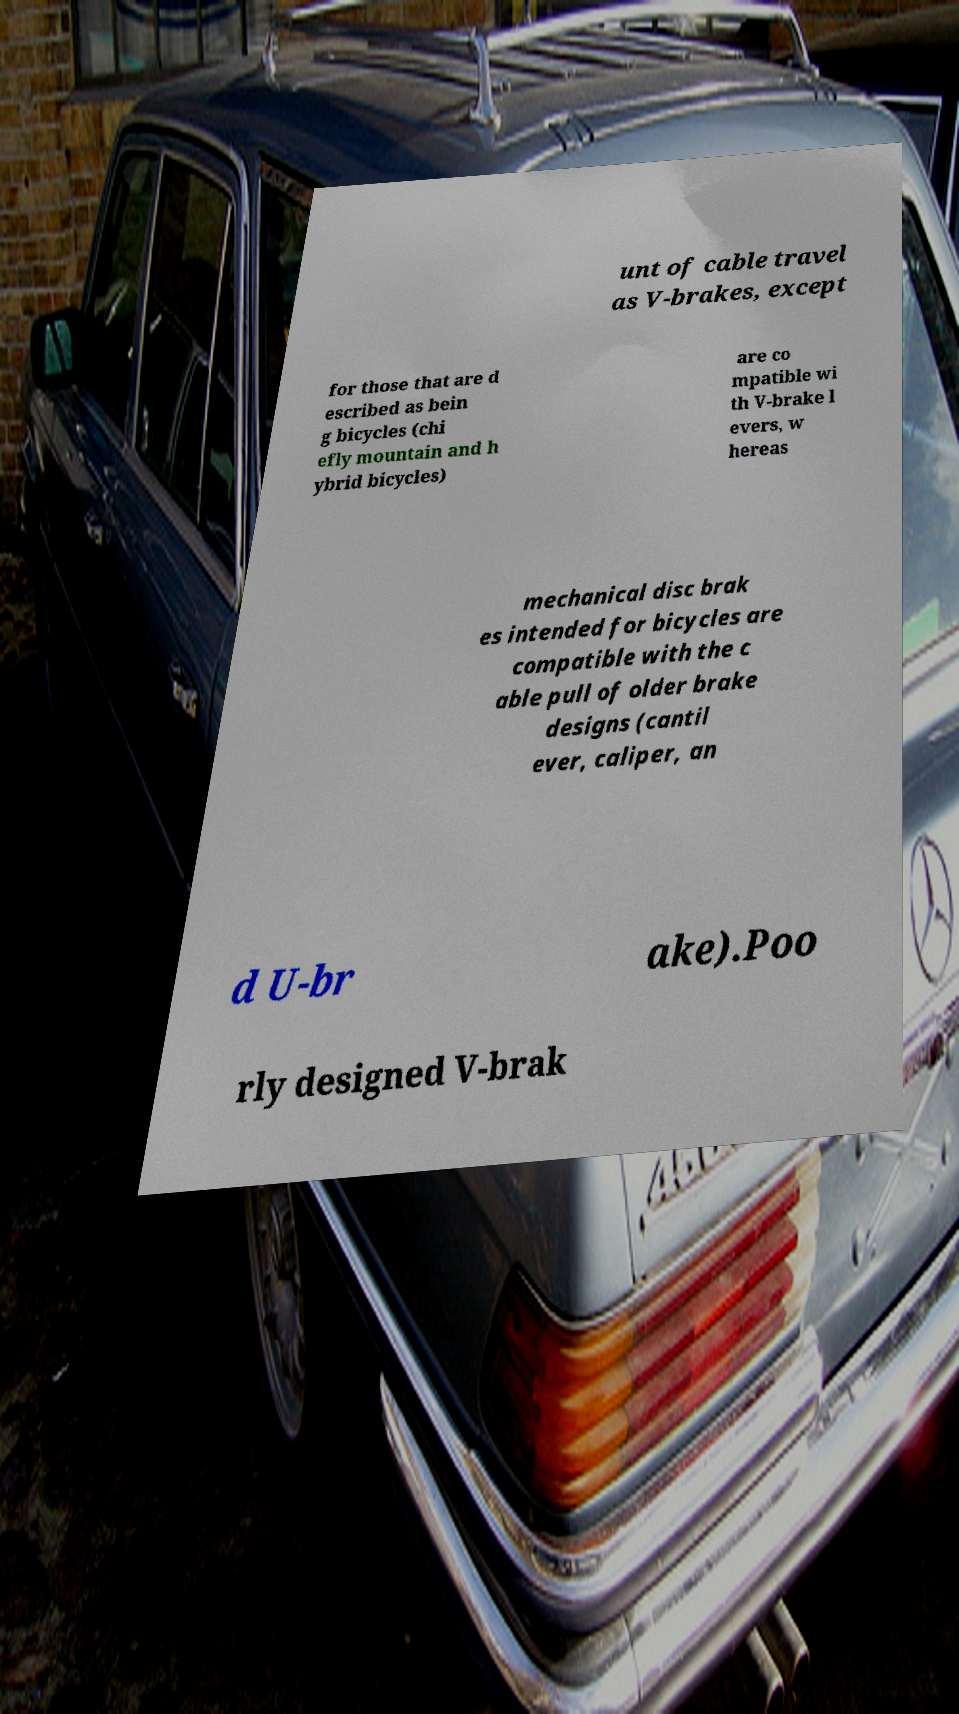What messages or text are displayed in this image? I need them in a readable, typed format. unt of cable travel as V-brakes, except for those that are d escribed as bein g bicycles (chi efly mountain and h ybrid bicycles) are co mpatible wi th V-brake l evers, w hereas mechanical disc brak es intended for bicycles are compatible with the c able pull of older brake designs (cantil ever, caliper, an d U-br ake).Poo rly designed V-brak 